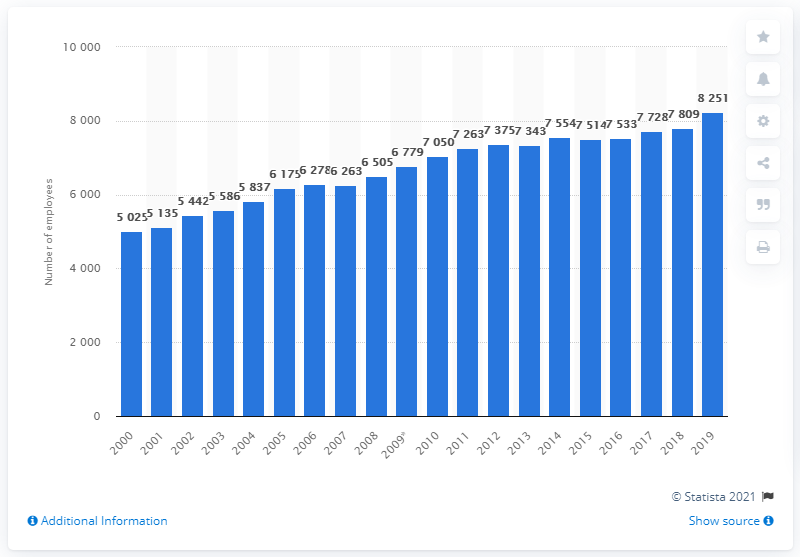Draw attention to some important aspects in this diagram. In 2019, there were 8,251 obstetricians and gynecologists employed in the health sector. In 2000, there were 8,251 obstetricians and gynecologists employed in the health sector. 